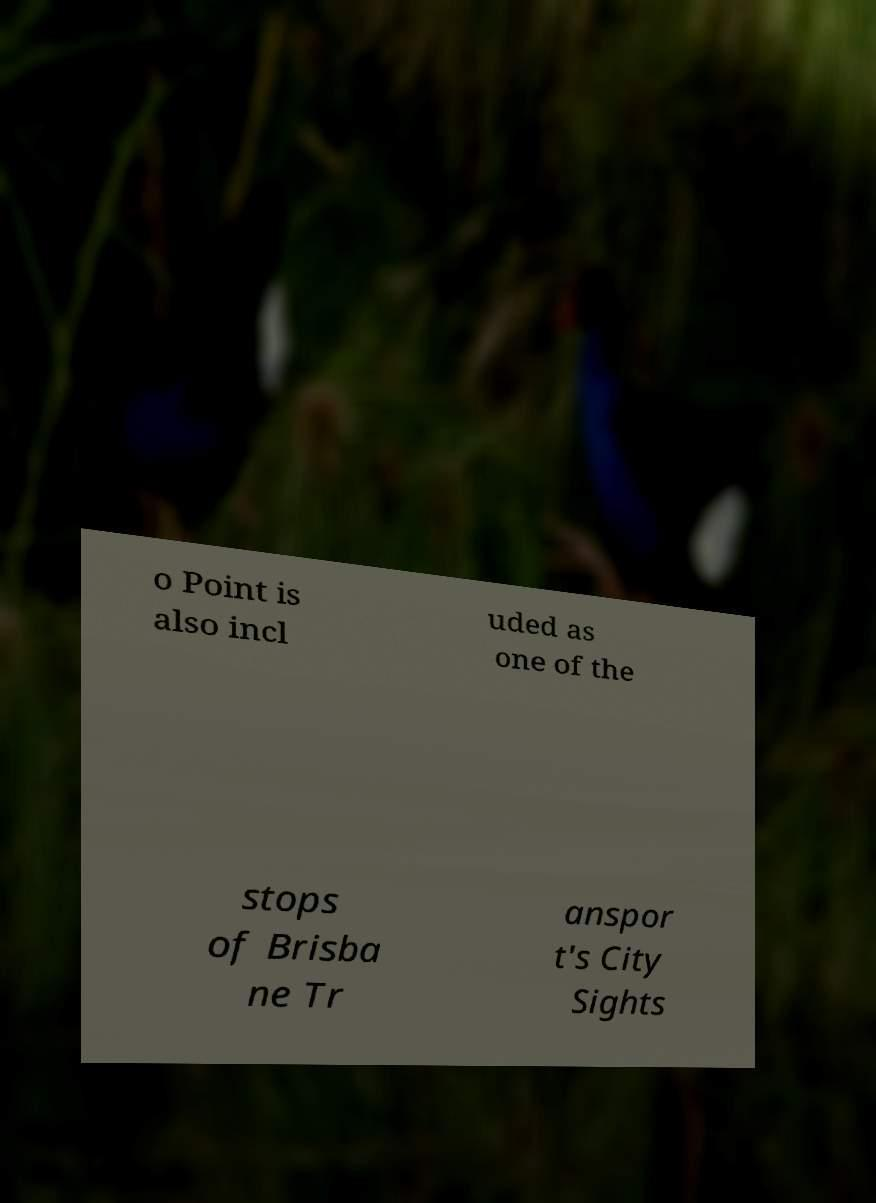What messages or text are displayed in this image? I need them in a readable, typed format. o Point is also incl uded as one of the stops of Brisba ne Tr anspor t's City Sights 